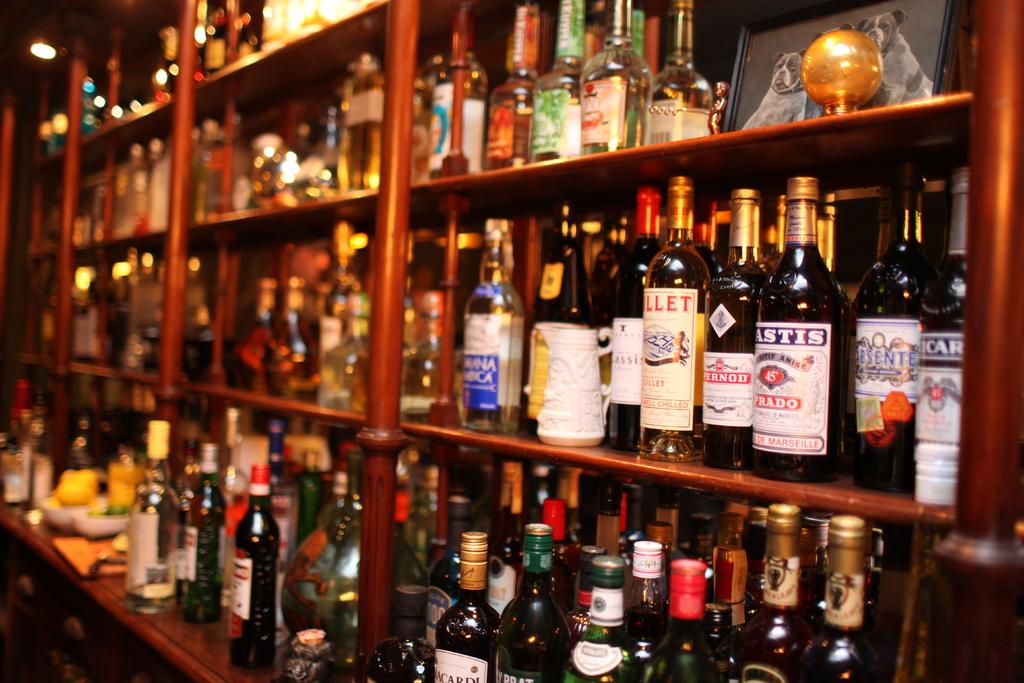What is the main object in the image? There is a rack in the image. What is the rack filled with? The rack is filled with bottles. What type of flowers can be seen growing on the rack in the image? There are no flowers present on the rack in the image; it is filled with bottles. 